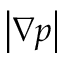<formula> <loc_0><loc_0><loc_500><loc_500>\left | \nabla p \right |</formula> 